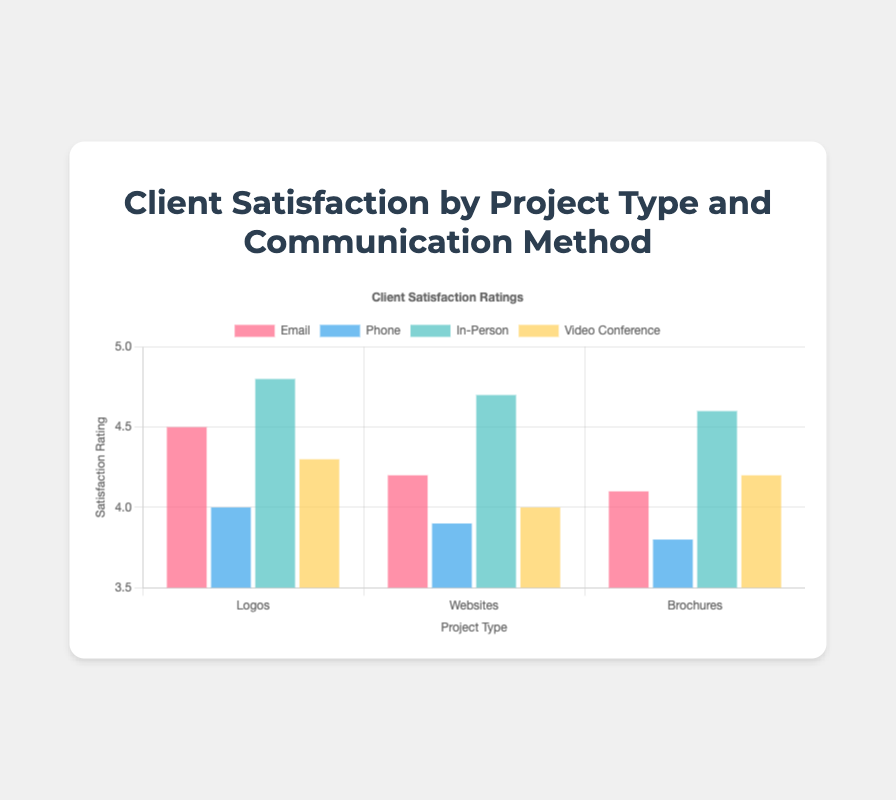What communication method resulted in the highest satisfaction rating for logos? For logos, look at the bar heights; the tallest bar corresponds to In-Person communication.
Answer: In-Person Which has a higher satisfaction rating for websites: Phone or Video Conference? Compare the heights of the bars for Phone and Video Conference under Websites. Video Conference has a higher bar.
Answer: Video Conference Between email and in-person, which communication method has varying ratings across project types? Check variation in bar heights across project types for Email (slight variation) and In-Person (consistent high values).
Answer: Email Compare the overall highest ratings between logos, websites, and brochures. Which project type comes out on top? Identify the single tallest bar from each project type: Logos (4.8), Websites (4.7), and Brochures (4.6). Logos have the highest single rating.
Answer: Logos For which project type and communication method combination is the satisfaction rating exactly 4.1? Look at the height of the bars and find 4.1; that corresponds to Brochures via Email.
Answer: Brochures, Email Which communication method has the most consistent satisfaction ratings across all project types? Look for the method where bars are closest in height for all project types: In-Person shows the least variability.
Answer: In-Person 